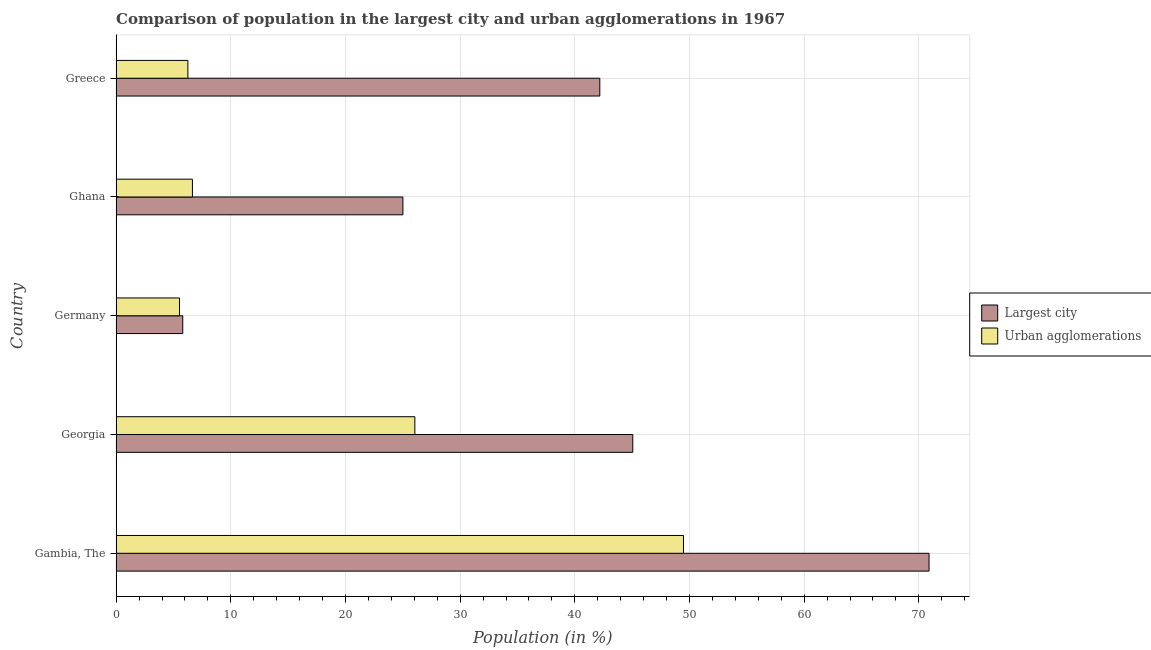How many different coloured bars are there?
Your answer should be compact. 2. Are the number of bars per tick equal to the number of legend labels?
Your response must be concise. Yes. What is the population in the largest city in Greece?
Your answer should be very brief. 42.18. Across all countries, what is the maximum population in the largest city?
Your answer should be compact. 70.89. Across all countries, what is the minimum population in the largest city?
Ensure brevity in your answer.  5.81. In which country was the population in the largest city maximum?
Keep it short and to the point. Gambia, The. What is the total population in the largest city in the graph?
Ensure brevity in your answer.  188.95. What is the difference between the population in the largest city in Gambia, The and that in Greece?
Ensure brevity in your answer.  28.71. What is the difference between the population in urban agglomerations in Germany and the population in the largest city in Greece?
Keep it short and to the point. -36.65. What is the average population in urban agglomerations per country?
Ensure brevity in your answer.  18.79. What is the difference between the population in urban agglomerations and population in the largest city in Greece?
Your answer should be very brief. -35.92. What is the ratio of the population in the largest city in Gambia, The to that in Georgia?
Your answer should be very brief. 1.57. Is the difference between the population in urban agglomerations in Georgia and Ghana greater than the difference between the population in the largest city in Georgia and Ghana?
Ensure brevity in your answer.  No. What is the difference between the highest and the second highest population in urban agglomerations?
Make the answer very short. 23.43. What is the difference between the highest and the lowest population in urban agglomerations?
Your response must be concise. 43.95. In how many countries, is the population in urban agglomerations greater than the average population in urban agglomerations taken over all countries?
Your answer should be compact. 2. Is the sum of the population in urban agglomerations in Georgia and Greece greater than the maximum population in the largest city across all countries?
Make the answer very short. No. What does the 1st bar from the top in Greece represents?
Your response must be concise. Urban agglomerations. What does the 1st bar from the bottom in Greece represents?
Your answer should be compact. Largest city. How many bars are there?
Your response must be concise. 10. How many countries are there in the graph?
Ensure brevity in your answer.  5. What is the difference between two consecutive major ticks on the X-axis?
Offer a terse response. 10. Are the values on the major ticks of X-axis written in scientific E-notation?
Give a very brief answer. No. Where does the legend appear in the graph?
Your response must be concise. Center right. How are the legend labels stacked?
Your answer should be compact. Vertical. What is the title of the graph?
Your answer should be very brief. Comparison of population in the largest city and urban agglomerations in 1967. Does "Age 15+" appear as one of the legend labels in the graph?
Provide a short and direct response. No. What is the label or title of the X-axis?
Give a very brief answer. Population (in %). What is the Population (in %) in Largest city in Gambia, The?
Offer a very short reply. 70.89. What is the Population (in %) in Urban agglomerations in Gambia, The?
Your answer should be compact. 49.48. What is the Population (in %) of Largest city in Georgia?
Provide a short and direct response. 45.06. What is the Population (in %) in Urban agglomerations in Georgia?
Your response must be concise. 26.05. What is the Population (in %) in Largest city in Germany?
Give a very brief answer. 5.81. What is the Population (in %) in Urban agglomerations in Germany?
Give a very brief answer. 5.53. What is the Population (in %) of Largest city in Ghana?
Provide a short and direct response. 25.01. What is the Population (in %) in Urban agglomerations in Ghana?
Provide a succinct answer. 6.65. What is the Population (in %) of Largest city in Greece?
Provide a succinct answer. 42.18. What is the Population (in %) of Urban agglomerations in Greece?
Provide a short and direct response. 6.26. Across all countries, what is the maximum Population (in %) in Largest city?
Make the answer very short. 70.89. Across all countries, what is the maximum Population (in %) in Urban agglomerations?
Your answer should be very brief. 49.48. Across all countries, what is the minimum Population (in %) of Largest city?
Your answer should be very brief. 5.81. Across all countries, what is the minimum Population (in %) in Urban agglomerations?
Provide a short and direct response. 5.53. What is the total Population (in %) in Largest city in the graph?
Offer a very short reply. 188.95. What is the total Population (in %) of Urban agglomerations in the graph?
Your answer should be compact. 93.97. What is the difference between the Population (in %) of Largest city in Gambia, The and that in Georgia?
Give a very brief answer. 25.84. What is the difference between the Population (in %) of Urban agglomerations in Gambia, The and that in Georgia?
Your response must be concise. 23.43. What is the difference between the Population (in %) in Largest city in Gambia, The and that in Germany?
Ensure brevity in your answer.  65.08. What is the difference between the Population (in %) of Urban agglomerations in Gambia, The and that in Germany?
Your response must be concise. 43.95. What is the difference between the Population (in %) in Largest city in Gambia, The and that in Ghana?
Provide a succinct answer. 45.88. What is the difference between the Population (in %) in Urban agglomerations in Gambia, The and that in Ghana?
Offer a very short reply. 42.83. What is the difference between the Population (in %) in Largest city in Gambia, The and that in Greece?
Your answer should be compact. 28.71. What is the difference between the Population (in %) in Urban agglomerations in Gambia, The and that in Greece?
Offer a very short reply. 43.22. What is the difference between the Population (in %) in Largest city in Georgia and that in Germany?
Your answer should be very brief. 39.25. What is the difference between the Population (in %) of Urban agglomerations in Georgia and that in Germany?
Offer a very short reply. 20.52. What is the difference between the Population (in %) of Largest city in Georgia and that in Ghana?
Your response must be concise. 20.05. What is the difference between the Population (in %) of Urban agglomerations in Georgia and that in Ghana?
Provide a short and direct response. 19.4. What is the difference between the Population (in %) of Largest city in Georgia and that in Greece?
Offer a very short reply. 2.87. What is the difference between the Population (in %) in Urban agglomerations in Georgia and that in Greece?
Provide a succinct answer. 19.79. What is the difference between the Population (in %) of Largest city in Germany and that in Ghana?
Your answer should be very brief. -19.2. What is the difference between the Population (in %) in Urban agglomerations in Germany and that in Ghana?
Your answer should be compact. -1.13. What is the difference between the Population (in %) in Largest city in Germany and that in Greece?
Your answer should be compact. -36.37. What is the difference between the Population (in %) of Urban agglomerations in Germany and that in Greece?
Offer a very short reply. -0.73. What is the difference between the Population (in %) of Largest city in Ghana and that in Greece?
Give a very brief answer. -17.17. What is the difference between the Population (in %) in Urban agglomerations in Ghana and that in Greece?
Offer a very short reply. 0.4. What is the difference between the Population (in %) in Largest city in Gambia, The and the Population (in %) in Urban agglomerations in Georgia?
Provide a succinct answer. 44.84. What is the difference between the Population (in %) in Largest city in Gambia, The and the Population (in %) in Urban agglomerations in Germany?
Your answer should be very brief. 65.37. What is the difference between the Population (in %) in Largest city in Gambia, The and the Population (in %) in Urban agglomerations in Ghana?
Make the answer very short. 64.24. What is the difference between the Population (in %) of Largest city in Gambia, The and the Population (in %) of Urban agglomerations in Greece?
Your answer should be very brief. 64.64. What is the difference between the Population (in %) of Largest city in Georgia and the Population (in %) of Urban agglomerations in Germany?
Keep it short and to the point. 39.53. What is the difference between the Population (in %) of Largest city in Georgia and the Population (in %) of Urban agglomerations in Ghana?
Give a very brief answer. 38.4. What is the difference between the Population (in %) of Largest city in Georgia and the Population (in %) of Urban agglomerations in Greece?
Make the answer very short. 38.8. What is the difference between the Population (in %) of Largest city in Germany and the Population (in %) of Urban agglomerations in Ghana?
Keep it short and to the point. -0.84. What is the difference between the Population (in %) in Largest city in Germany and the Population (in %) in Urban agglomerations in Greece?
Your answer should be compact. -0.45. What is the difference between the Population (in %) of Largest city in Ghana and the Population (in %) of Urban agglomerations in Greece?
Give a very brief answer. 18.75. What is the average Population (in %) of Largest city per country?
Offer a terse response. 37.79. What is the average Population (in %) in Urban agglomerations per country?
Ensure brevity in your answer.  18.79. What is the difference between the Population (in %) in Largest city and Population (in %) in Urban agglomerations in Gambia, The?
Keep it short and to the point. 21.41. What is the difference between the Population (in %) in Largest city and Population (in %) in Urban agglomerations in Georgia?
Ensure brevity in your answer.  19. What is the difference between the Population (in %) of Largest city and Population (in %) of Urban agglomerations in Germany?
Keep it short and to the point. 0.28. What is the difference between the Population (in %) of Largest city and Population (in %) of Urban agglomerations in Ghana?
Your answer should be very brief. 18.36. What is the difference between the Population (in %) of Largest city and Population (in %) of Urban agglomerations in Greece?
Offer a very short reply. 35.92. What is the ratio of the Population (in %) in Largest city in Gambia, The to that in Georgia?
Your response must be concise. 1.57. What is the ratio of the Population (in %) of Urban agglomerations in Gambia, The to that in Georgia?
Ensure brevity in your answer.  1.9. What is the ratio of the Population (in %) in Largest city in Gambia, The to that in Germany?
Make the answer very short. 12.2. What is the ratio of the Population (in %) of Urban agglomerations in Gambia, The to that in Germany?
Your answer should be very brief. 8.95. What is the ratio of the Population (in %) of Largest city in Gambia, The to that in Ghana?
Your answer should be compact. 2.83. What is the ratio of the Population (in %) in Urban agglomerations in Gambia, The to that in Ghana?
Your answer should be compact. 7.44. What is the ratio of the Population (in %) in Largest city in Gambia, The to that in Greece?
Your response must be concise. 1.68. What is the ratio of the Population (in %) of Urban agglomerations in Gambia, The to that in Greece?
Offer a very short reply. 7.91. What is the ratio of the Population (in %) in Largest city in Georgia to that in Germany?
Keep it short and to the point. 7.76. What is the ratio of the Population (in %) in Urban agglomerations in Georgia to that in Germany?
Keep it short and to the point. 4.71. What is the ratio of the Population (in %) in Largest city in Georgia to that in Ghana?
Provide a short and direct response. 1.8. What is the ratio of the Population (in %) of Urban agglomerations in Georgia to that in Ghana?
Keep it short and to the point. 3.92. What is the ratio of the Population (in %) in Largest city in Georgia to that in Greece?
Provide a short and direct response. 1.07. What is the ratio of the Population (in %) of Urban agglomerations in Georgia to that in Greece?
Keep it short and to the point. 4.16. What is the ratio of the Population (in %) of Largest city in Germany to that in Ghana?
Keep it short and to the point. 0.23. What is the ratio of the Population (in %) in Urban agglomerations in Germany to that in Ghana?
Keep it short and to the point. 0.83. What is the ratio of the Population (in %) of Largest city in Germany to that in Greece?
Provide a succinct answer. 0.14. What is the ratio of the Population (in %) in Urban agglomerations in Germany to that in Greece?
Provide a short and direct response. 0.88. What is the ratio of the Population (in %) in Largest city in Ghana to that in Greece?
Ensure brevity in your answer.  0.59. What is the ratio of the Population (in %) in Urban agglomerations in Ghana to that in Greece?
Your answer should be very brief. 1.06. What is the difference between the highest and the second highest Population (in %) in Largest city?
Your answer should be very brief. 25.84. What is the difference between the highest and the second highest Population (in %) of Urban agglomerations?
Your response must be concise. 23.43. What is the difference between the highest and the lowest Population (in %) of Largest city?
Provide a short and direct response. 65.08. What is the difference between the highest and the lowest Population (in %) in Urban agglomerations?
Ensure brevity in your answer.  43.95. 